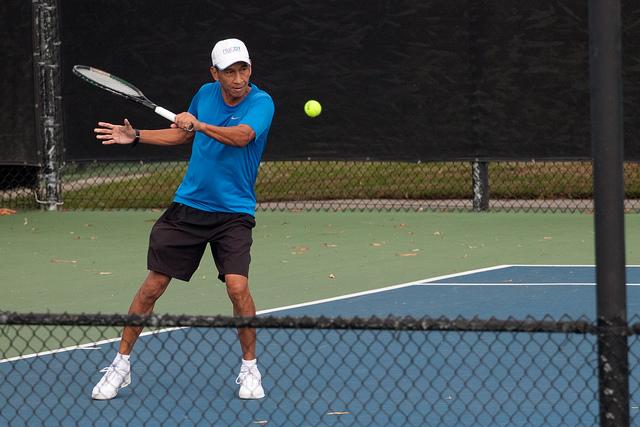What letter is on the tennis racket?
Give a very brief answer. W. Are those leaves on the tennis court?
Concise answer only. Yes. What color is his shirt?
Quick response, please. Blue. Is the man playing tennis in a stadium?
Keep it brief. No. 